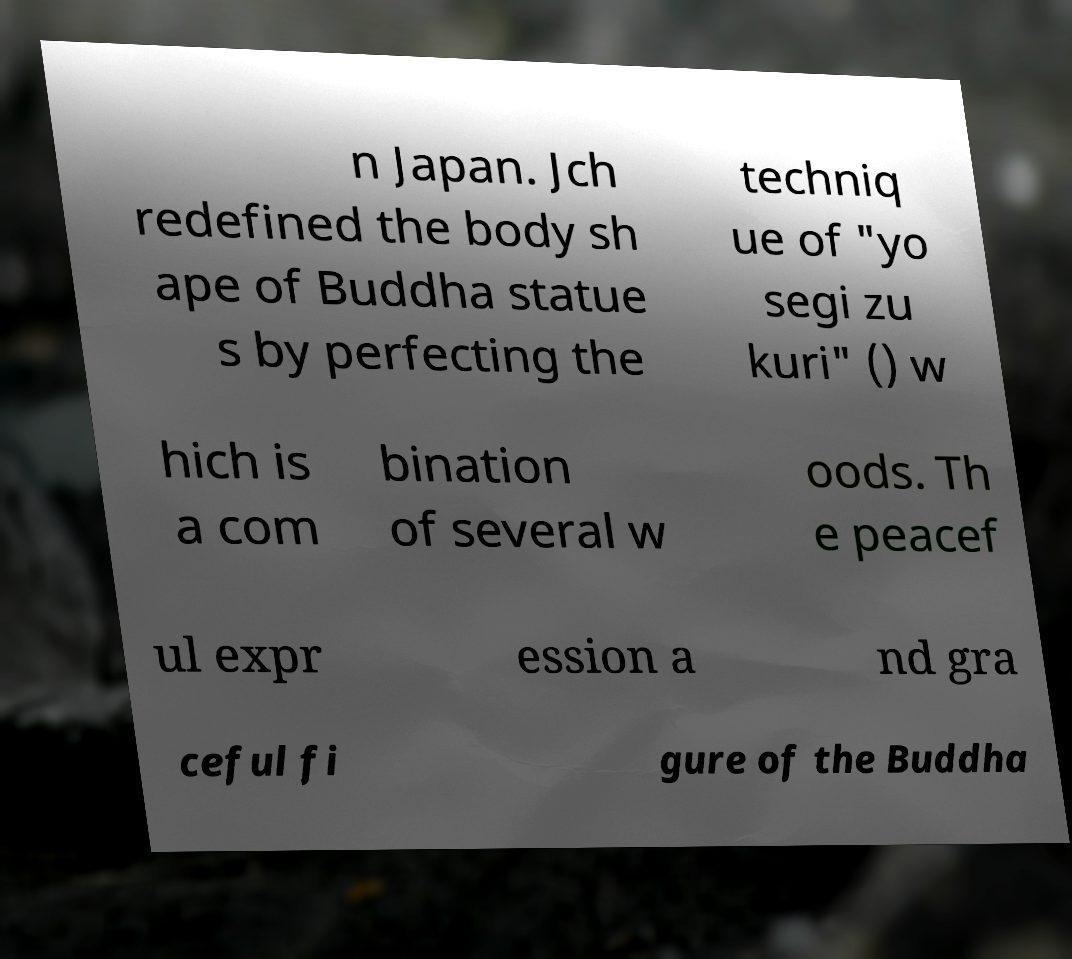Can you read and provide the text displayed in the image?This photo seems to have some interesting text. Can you extract and type it out for me? n Japan. Jch redefined the body sh ape of Buddha statue s by perfecting the techniq ue of "yo segi zu kuri" () w hich is a com bination of several w oods. Th e peacef ul expr ession a nd gra ceful fi gure of the Buddha 